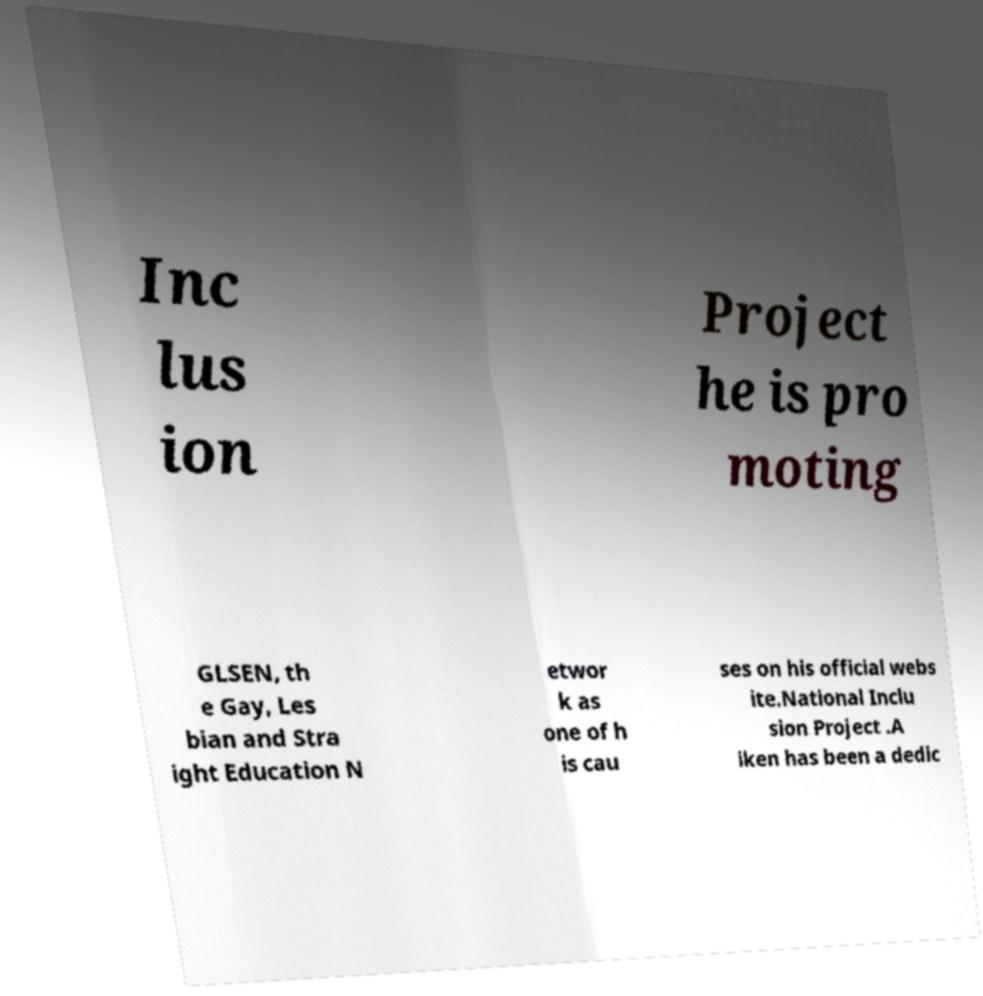For documentation purposes, I need the text within this image transcribed. Could you provide that? Inc lus ion Project he is pro moting GLSEN, th e Gay, Les bian and Stra ight Education N etwor k as one of h is cau ses on his official webs ite.National Inclu sion Project .A iken has been a dedic 